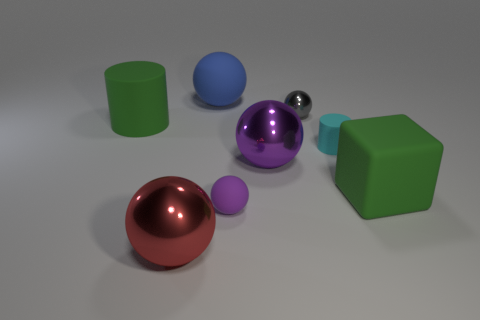Subtract all gray spheres. How many spheres are left? 4 Subtract all big purple metal spheres. How many spheres are left? 4 Subtract all yellow balls. Subtract all red cylinders. How many balls are left? 5 Add 1 large red things. How many objects exist? 9 Subtract all cylinders. How many objects are left? 6 Subtract 1 gray spheres. How many objects are left? 7 Subtract all big matte cylinders. Subtract all big cubes. How many objects are left? 6 Add 1 matte balls. How many matte balls are left? 3 Add 1 large yellow rubber spheres. How many large yellow rubber spheres exist? 1 